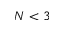Convert formula to latex. <formula><loc_0><loc_0><loc_500><loc_500>N < 3</formula> 